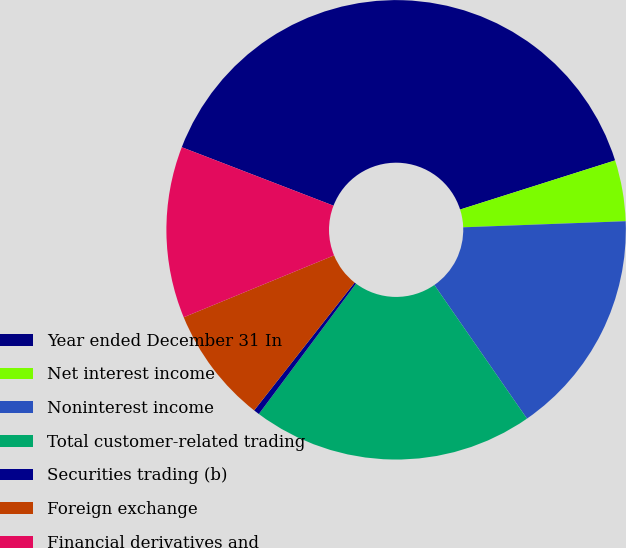<chart> <loc_0><loc_0><loc_500><loc_500><pie_chart><fcel>Year ended December 31 In<fcel>Net interest income<fcel>Noninterest income<fcel>Total customer-related trading<fcel>Securities trading (b)<fcel>Foreign exchange<fcel>Financial derivatives and<nl><fcel>39.26%<fcel>4.29%<fcel>15.95%<fcel>19.84%<fcel>0.41%<fcel>8.18%<fcel>12.07%<nl></chart> 